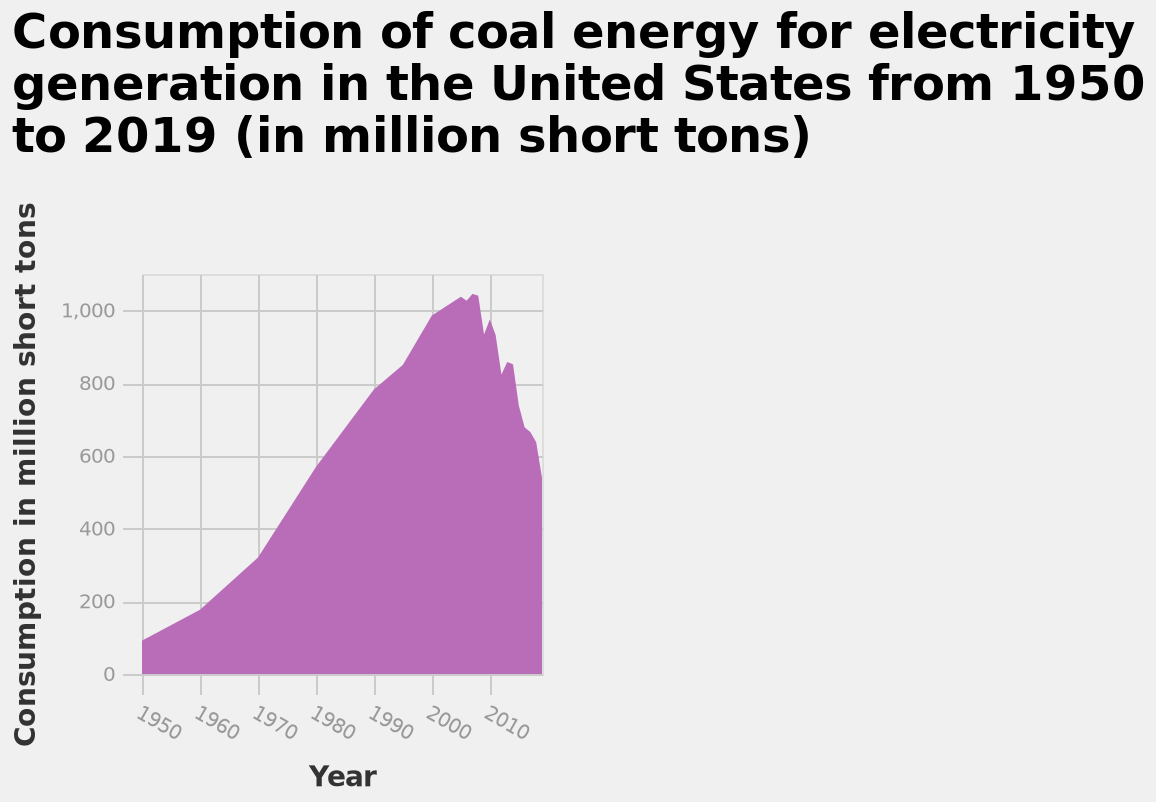<image>
What is the range of the y-axis in the graph?  The range of the y-axis in the graph is from 0 to 1000, increasing in sums of 200. What is the highest value displayed on the y-axis of the area diagram? The highest value displayed on the y-axis is 1,000 million short tons. Is the lowest value displayed on the y-axis 1,000 million short tons? No.The highest value displayed on the y-axis is 1,000 million short tons. 